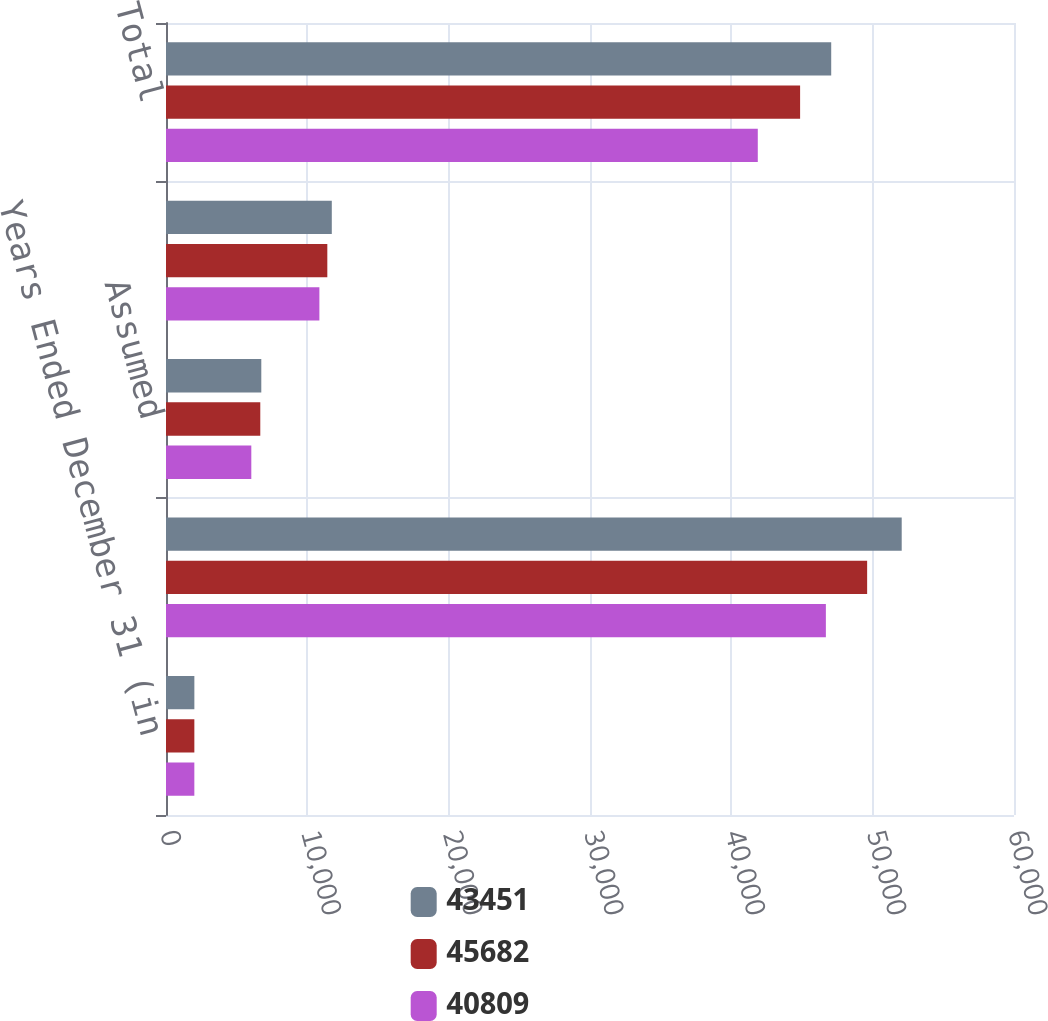<chart> <loc_0><loc_0><loc_500><loc_500><stacked_bar_chart><ecel><fcel>Years Ended December 31 (in<fcel>Direct<fcel>Assumed<fcel>Ceded<fcel>Total<nl><fcel>43451<fcel>2007<fcel>52055<fcel>6743<fcel>11731<fcel>47067<nl><fcel>45682<fcel>2006<fcel>49609<fcel>6671<fcel>11414<fcel>44866<nl><fcel>40809<fcel>2005<fcel>46689<fcel>6036<fcel>10853<fcel>41872<nl></chart> 